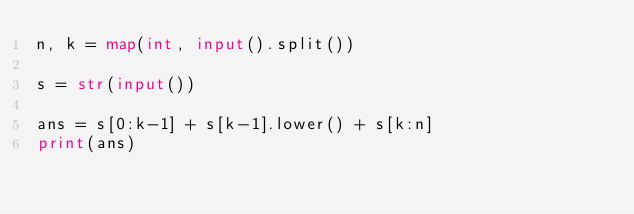<code> <loc_0><loc_0><loc_500><loc_500><_Python_>n, k = map(int, input().split())

s = str(input())

ans = s[0:k-1] + s[k-1].lower() + s[k:n]
print(ans)</code> 